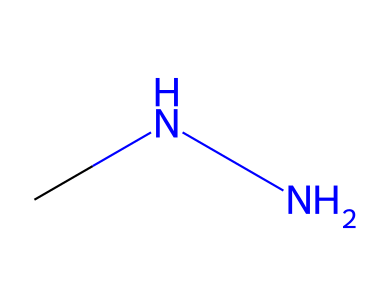what is the molecular formula of monomethylhydrazine? The SMILES representation CN[NH2] indicates that there is one carbon atom (C), two nitrogen atoms (N), and six hydrogen atoms (H), leading to the molecular formula of C2H8N2.
Answer: C2H8N2 how many nitrogen atoms are present in this structure? By inspecting the SMILES notation, one can see there are two nitrogen atoms represented by the two N in the formula.
Answer: 2 what type of compound is monomethylhydrazine? Monomethylhydrazine is classified as a hydrazine derivative, as indicated by the presence of the hydrazine functional group (N-N) with an additional methyl group (C).
Answer: hydrazine what is the primary functional group present in this chemical? The nitrogen atoms connected in the structure indicate the presence of an amine functional group due to the NH2 group.
Answer: amine why is monomethylhydrazine used in rocket fuel? Monomethylhydrazine is used as a hypergolic propellant, meaning it ignites spontaneously upon contact with an oxidizer, making it effective for rocket propulsion.
Answer: hypergolic how many hydrogen atoms are bonded to the nitrogen atoms in this structure? In the SMILES representation CN[NH2], the NH2 group indicates that there are two hydrogen atoms bonded to one nitrogen atom in the structure.
Answer: 2 what distinguishes monomethylhydrazine from other hydrazines? The presence of a methyl (CH3) group attached to one of the nitrogen atoms distinguishes monomethylhydrazine from other hydrazines, which may have different alkyl or substituent groups.
Answer: methyl group 